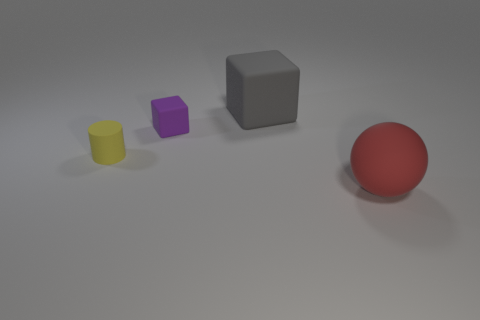How many big objects are either rubber cylinders or blue metallic cubes?
Your response must be concise. 0. What is the size of the matte thing that is behind the matte cube to the left of the block behind the purple matte cube?
Provide a short and direct response. Large. Are there any other things that have the same color as the tiny block?
Your response must be concise. No. There is a large thing that is on the left side of the large rubber thing that is in front of the big thing that is behind the red ball; what is its material?
Provide a short and direct response. Rubber. Is the purple matte object the same shape as the red thing?
Your response must be concise. No. How many rubber things are both to the right of the tiny purple matte cube and behind the red sphere?
Ensure brevity in your answer.  1. What color is the rubber thing right of the large object that is on the left side of the matte sphere?
Make the answer very short. Red. Are there the same number of small purple things that are right of the gray matte thing and red matte cubes?
Offer a very short reply. Yes. How many big gray objects are in front of the big object in front of the tiny matte thing to the left of the tiny cube?
Provide a short and direct response. 0. There is a large rubber thing right of the large gray block; what color is it?
Give a very brief answer. Red. 